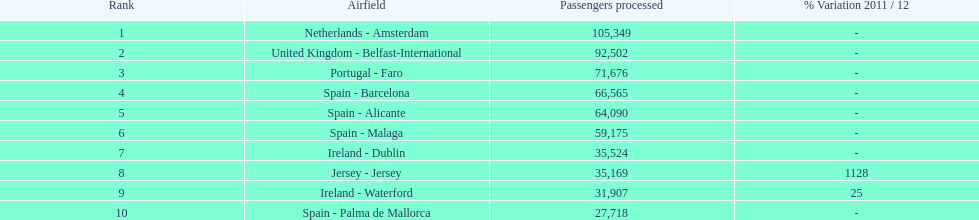How many passengers were handled in an airport in spain? 217,548. Parse the table in full. {'header': ['Rank', 'Airfield', 'Passengers processed', '% Variation 2011 / 12'], 'rows': [['1', 'Netherlands - Amsterdam', '105,349', '-'], ['2', 'United Kingdom - Belfast-International', '92,502', '-'], ['3', 'Portugal - Faro', '71,676', '-'], ['4', 'Spain - Barcelona', '66,565', '-'], ['5', 'Spain - Alicante', '64,090', '-'], ['6', 'Spain - Malaga', '59,175', '-'], ['7', 'Ireland - Dublin', '35,524', '-'], ['8', 'Jersey - Jersey', '35,169', '1128'], ['9', 'Ireland - Waterford', '31,907', '25'], ['10', 'Spain - Palma de Mallorca', '27,718', '-']]} 